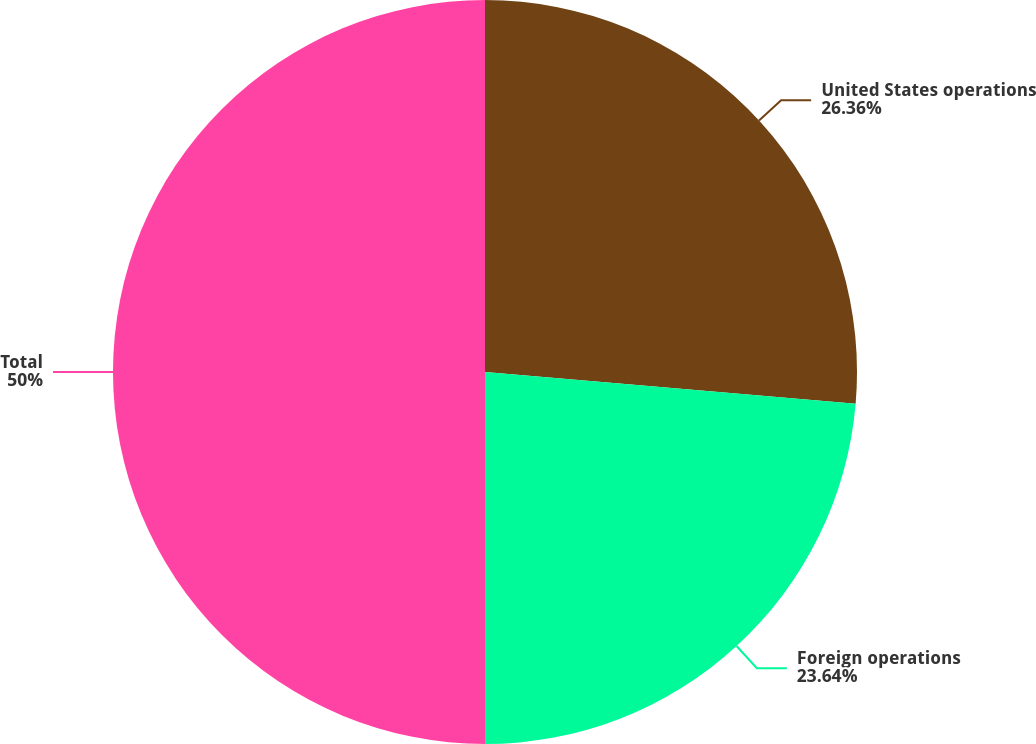Convert chart. <chart><loc_0><loc_0><loc_500><loc_500><pie_chart><fcel>United States operations<fcel>Foreign operations<fcel>Total<nl><fcel>26.36%<fcel>23.64%<fcel>50.0%<nl></chart> 